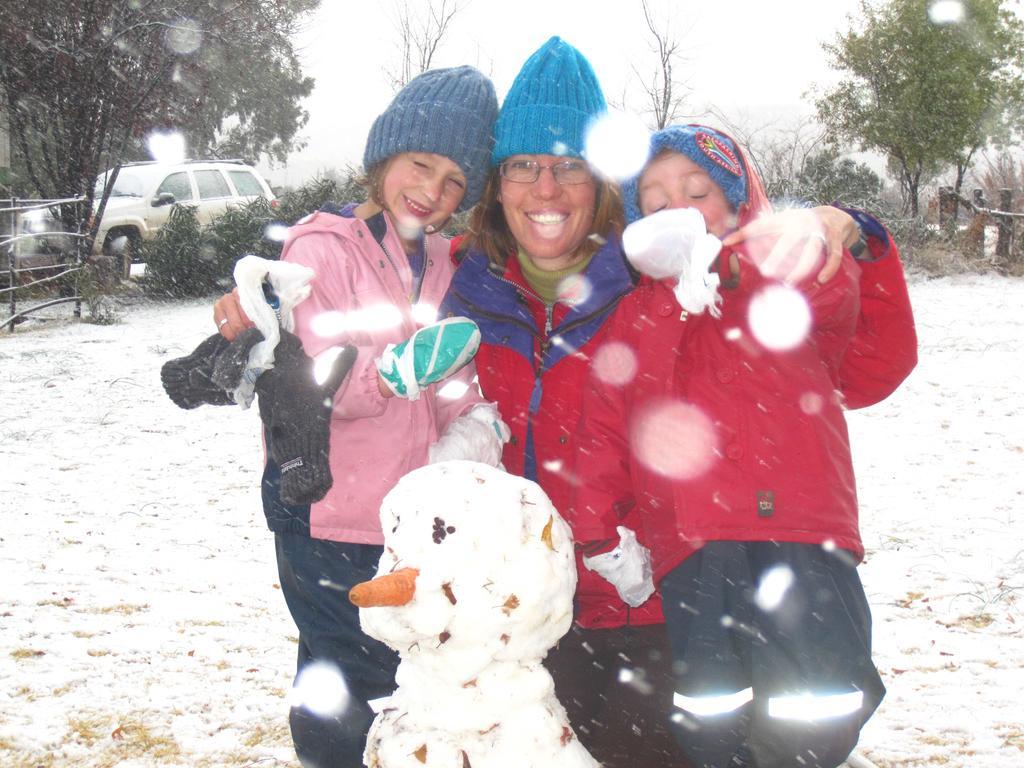Describe this image in one or two sentences. In this picture there is a lady and two girls in the center of the image on the snow floor and there is a car, trees, and boundaries in the background area of the image. 